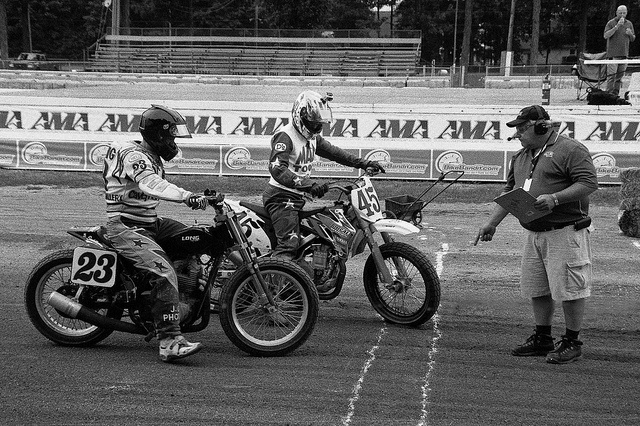Describe the objects in this image and their specific colors. I can see motorcycle in black, gray, darkgray, and lightgray tones, people in black, gray, and lightgray tones, people in black, gray, darkgray, and lightgray tones, motorcycle in black, gray, darkgray, and lightgray tones, and bench in black, gray, and lightgray tones in this image. 